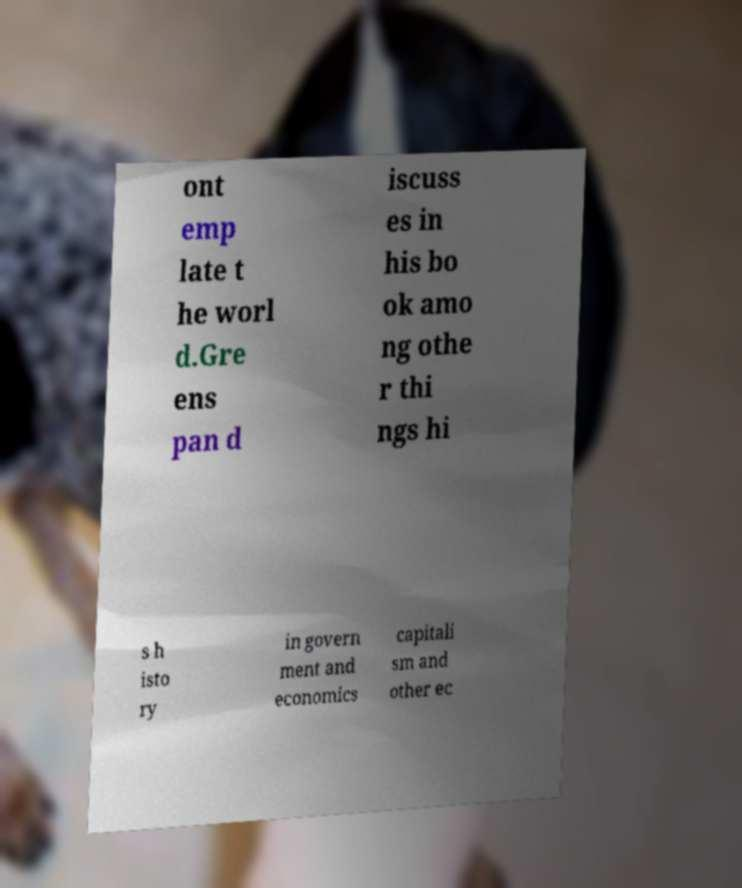Please identify and transcribe the text found in this image. ont emp late t he worl d.Gre ens pan d iscuss es in his bo ok amo ng othe r thi ngs hi s h isto ry in govern ment and economics capitali sm and other ec 